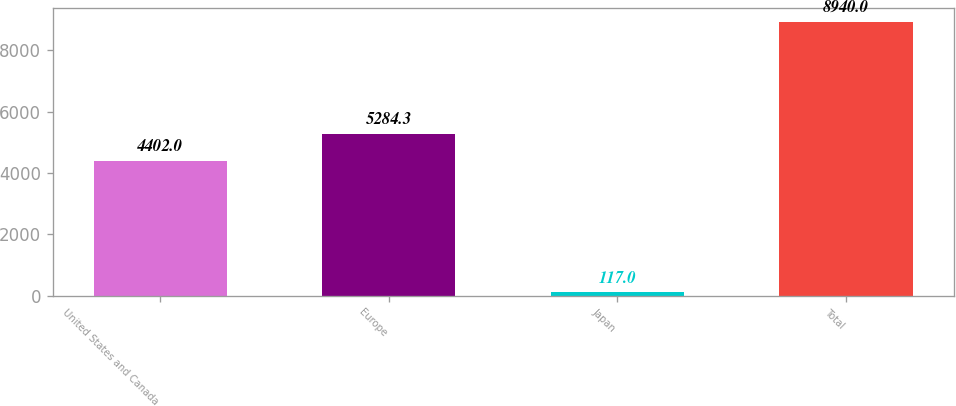Convert chart. <chart><loc_0><loc_0><loc_500><loc_500><bar_chart><fcel>United States and Canada<fcel>Europe<fcel>Japan<fcel>Total<nl><fcel>4402<fcel>5284.3<fcel>117<fcel>8940<nl></chart> 